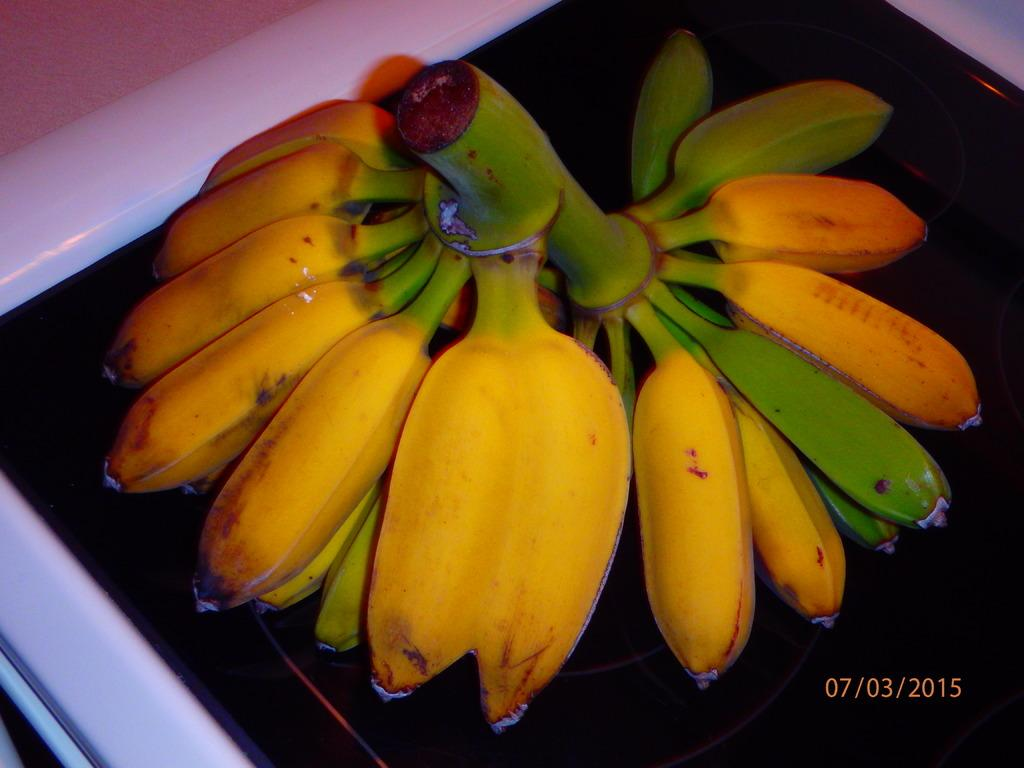What type of fruit can be seen on the table in the image? There are bananas on the table in the image. How many mice are hiding behind the bananas in the image? There are no mice present in the image; it only features bananas on the table. 